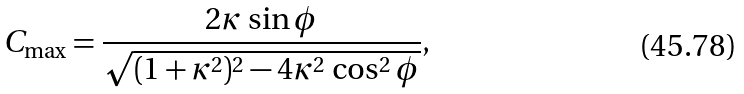<formula> <loc_0><loc_0><loc_500><loc_500>C _ { \max } = \frac { 2 \kappa \, \sin \phi } { \sqrt { ( 1 + \kappa ^ { 2 } ) ^ { 2 } - 4 \kappa ^ { 2 } \, \cos ^ { 2 } \phi } } ,</formula> 